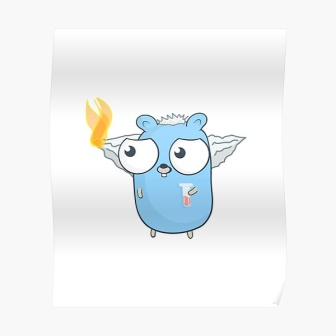What do you see happening in this image? The image showcases a delightful and whimsical creature that appears to be an imaginative fusion of different elements. Dominating a pristine white background, this bear-like creature stands on two legs and is primarily blue. It sports a pair of delicate wings on its back and has an enchanting flame burning atop its head, lending a fantastical charm. With its small red tongue cheekily sticking out, the creature exudes a playful and humorous essence. Positioned centrally in the image, it naturally draws the viewer’s focus. The clean composition, free of any text or extraneous objects, emphasizes the mythical character as the sole subject of interest, sparking curiosity about its story and nature. 